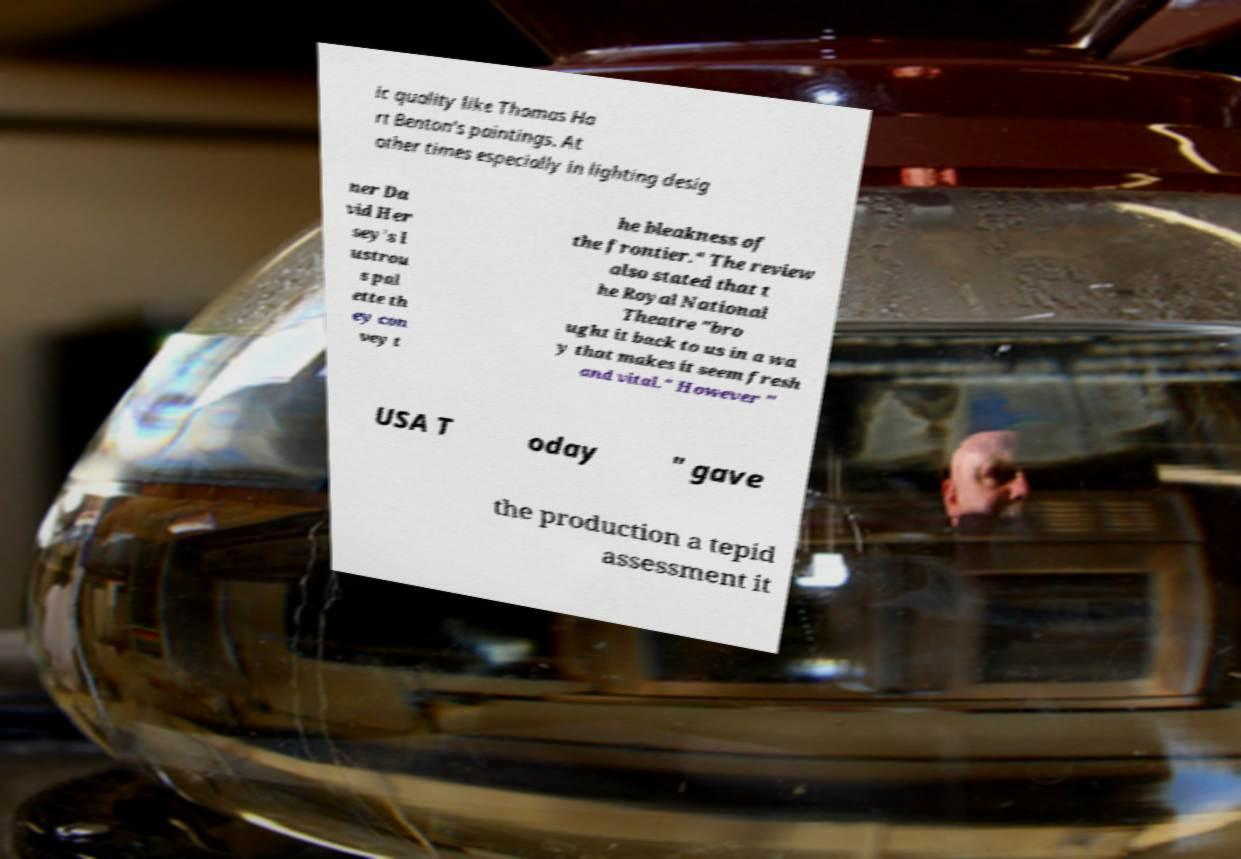Could you assist in decoding the text presented in this image and type it out clearly? ic quality like Thomas Ha rt Benton's paintings. At other times especially in lighting desig ner Da vid Her sey's l ustrou s pal ette th ey con vey t he bleakness of the frontier." The review also stated that t he Royal National Theatre "bro ught it back to us in a wa y that makes it seem fresh and vital." However " USA T oday " gave the production a tepid assessment it 